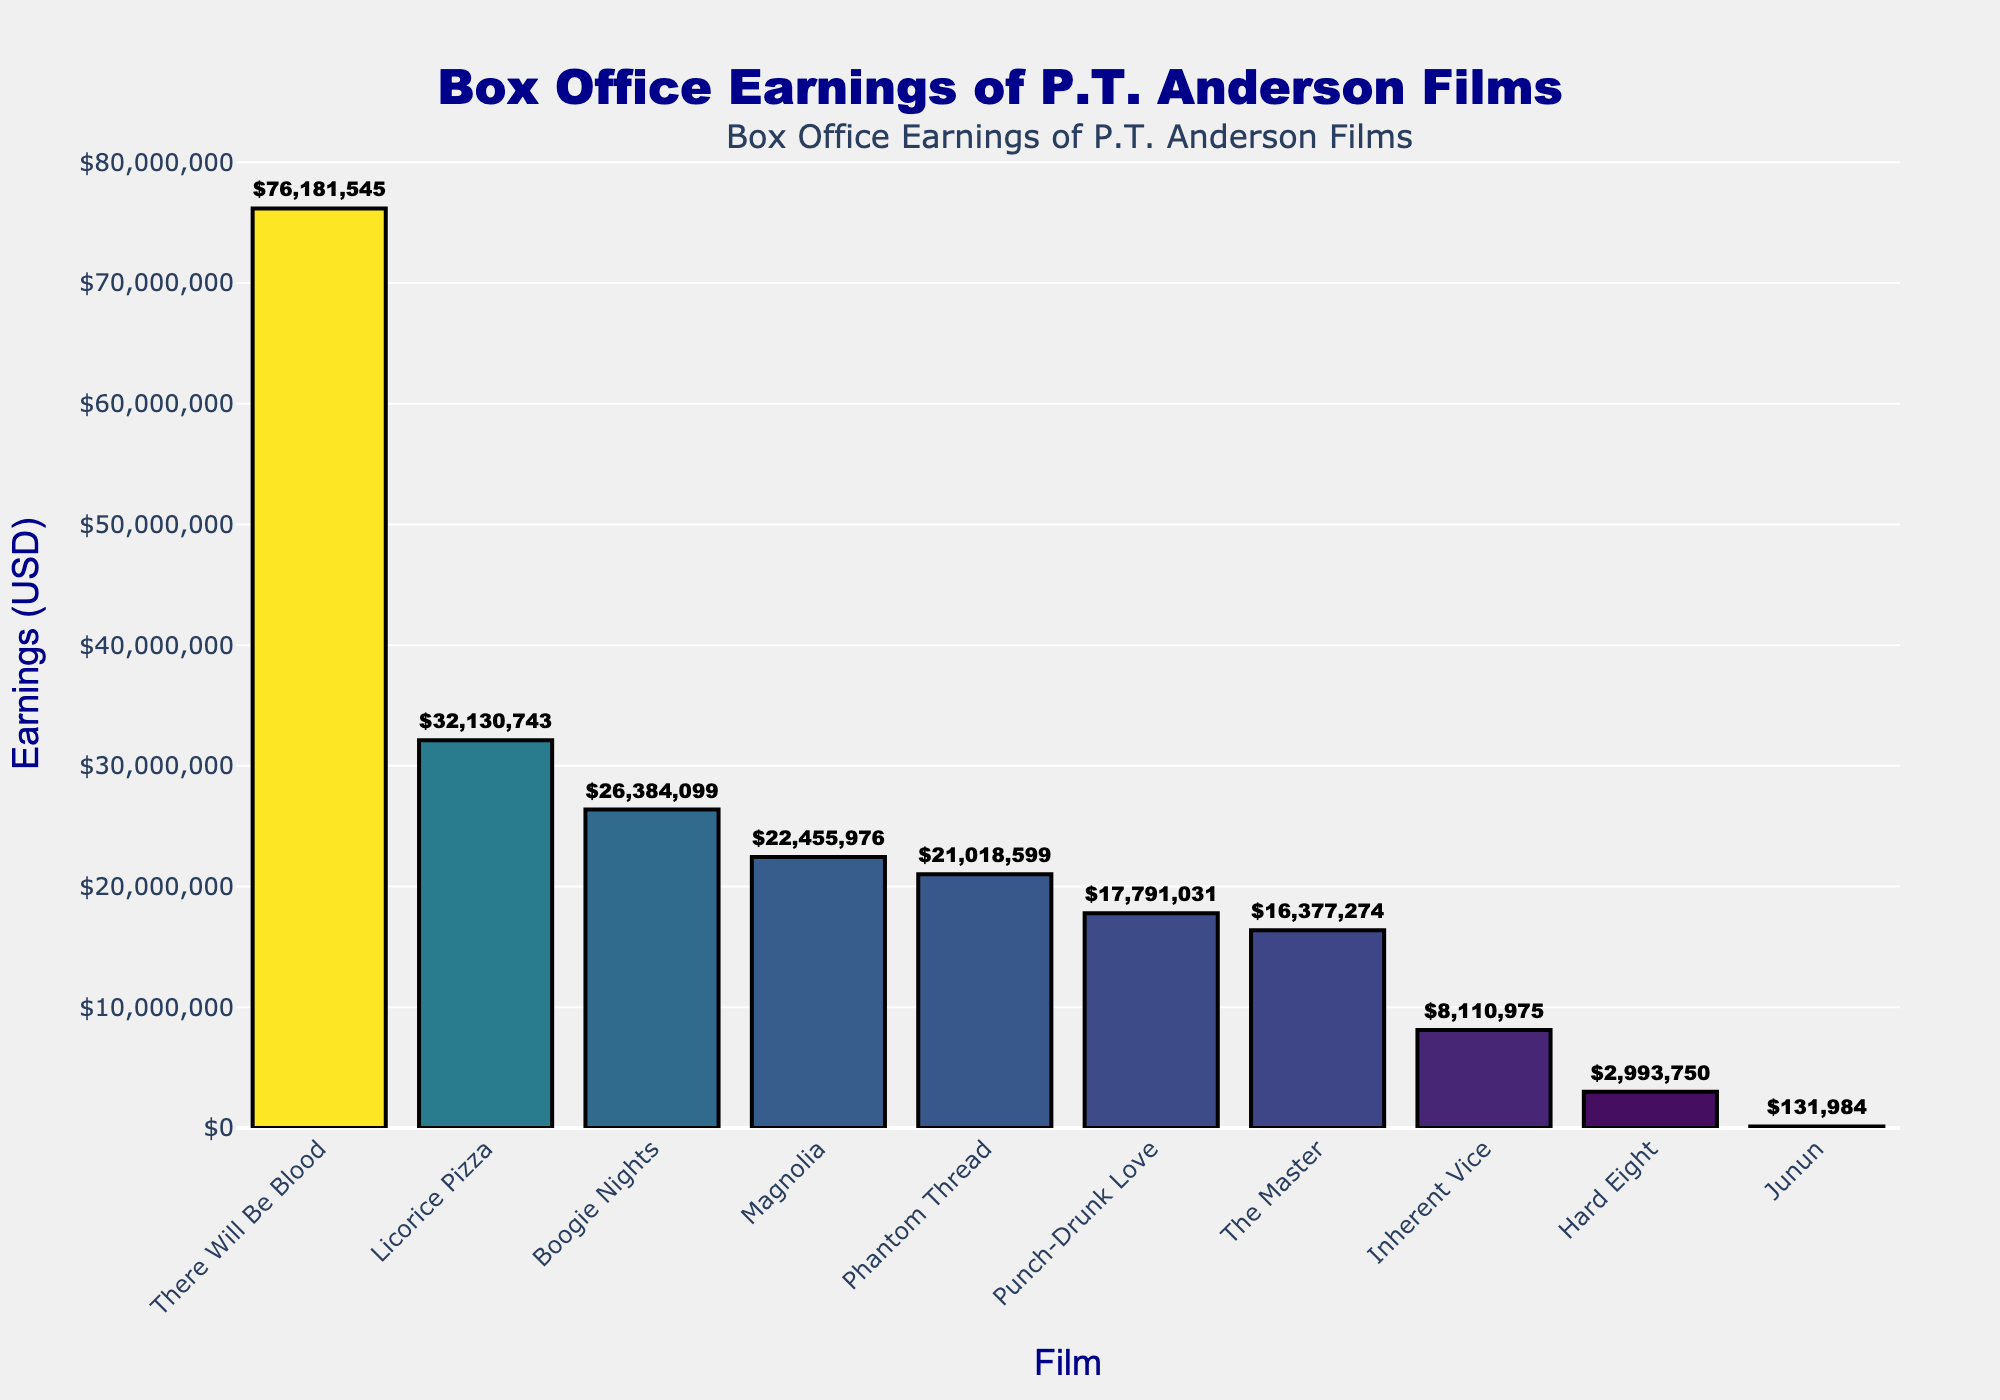Which P.T. Anderson film has the highest box office earnings? The film with the highest bar represents the highest earnings. "There Will Be Blood" has the tallest bar, indicating the highest earnings.
Answer: There Will Be Blood Which film earned more, "Boogie Nights" or "Magnolia"? By comparing the heights of their bars, "Boogie Nights" has a slightly taller bar than "Magnolia," indicating higher earnings.
Answer: Boogie Nights What is the combined box office earnings of "Phantom Thread" and "Inherent Vice"? Add the earnings of "Phantom Thread" ($21,018,599) and "Inherent Vice" ($8,110,975). The sum is $29,129,574.
Answer: $29,129,574 How does "Punch-Drunk Love" compare to "The Master" in terms of earnings? Compare their bar heights. "Punch-Drunk Love" has a higher bar than "The Master," indicating more earnings.
Answer: Punch-Drunk Love earned more What is the difference in earnings between "Licorice Pizza" and "The Master"? Subtract the earnings of "The Master" ($16,377,274) from "Licorice Pizza" ($32,130,743). The difference is $15,753,469.
Answer: $15,753,469 Which film has the lowest box office earnings, and how much did it earn? The shortest bar belongs to "Junun," indicating the lowest earnings. The earnings are $131,984.
Answer: Junun, $131,984 What is the total box office earnings of all the films combined? Add all the earnings: $76,181,545 + $32,130,743 + $21,018,599 + $26,384,099 + $22,455,976 + $17,791,031 + $16,377,274 + $8,110,975 + $2,993,750 + $131,984. The sum is $223,576,976.
Answer: $223,576,976 What is the average earnings of the films "Hard Eight" and "Junun"? Add the earnings of "Hard Eight" ($2,993,750) and "Junun" ($131,984). Divide the sum by 2: ($2,993,750 + $131,984) / 2 = $1,562,867.
Answer: $1,562,867 Which film has a higher difference in earnings compared to "Inherent Vice" than "Magnolia" does? "Inherent Vice" earned $8,110,975. "Magnolia" earned $22,455,976. Compute the difference for each film and compare: "There Will Be Blood" has a larger difference ($76,181,545 - $8,110,975 = $68,070,570) compared to "Magnolia" ($22,455,976 - $8,110,975 = $14,345,001). "There Will Be Blood" has a larger Difference.
Answer: There Will Be Blood 